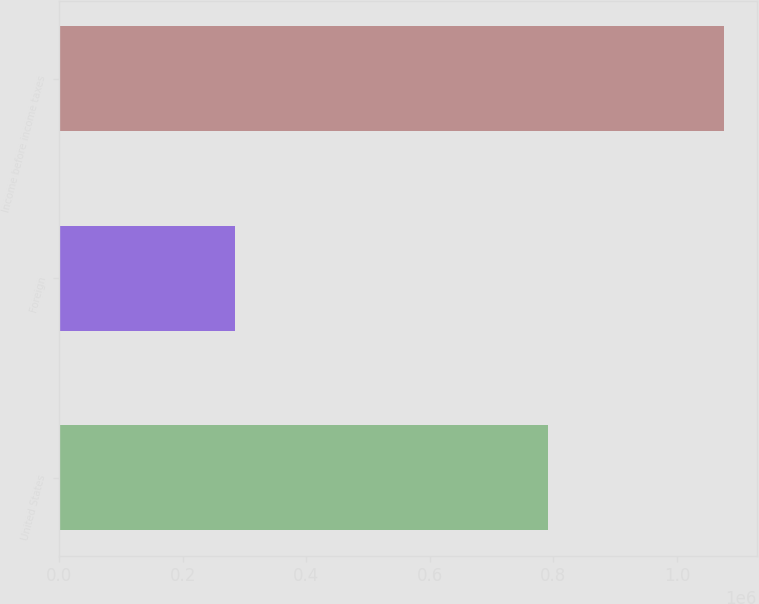<chart> <loc_0><loc_0><loc_500><loc_500><bar_chart><fcel>United States<fcel>Foreign<fcel>Income before income taxes<nl><fcel>790592<fcel>285020<fcel>1.07561e+06<nl></chart> 